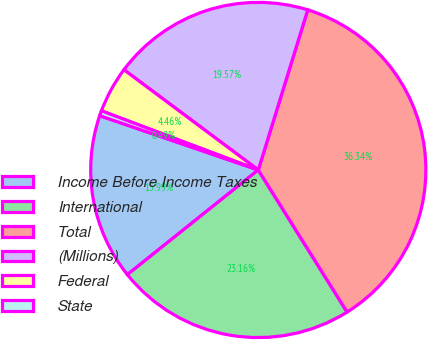Convert chart. <chart><loc_0><loc_0><loc_500><loc_500><pie_chart><fcel>Income Before Income Taxes<fcel>International<fcel>Total<fcel>(Millions)<fcel>Federal<fcel>State<nl><fcel>15.99%<fcel>23.16%<fcel>36.34%<fcel>19.57%<fcel>4.46%<fcel>0.49%<nl></chart> 